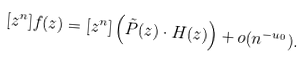Convert formula to latex. <formula><loc_0><loc_0><loc_500><loc_500>[ z ^ { n } ] f ( z ) = [ z ^ { n } ] \left ( \tilde { P } ( z ) \cdot H ( z ) \right ) + o ( n ^ { - u _ { 0 } } ) .</formula> 